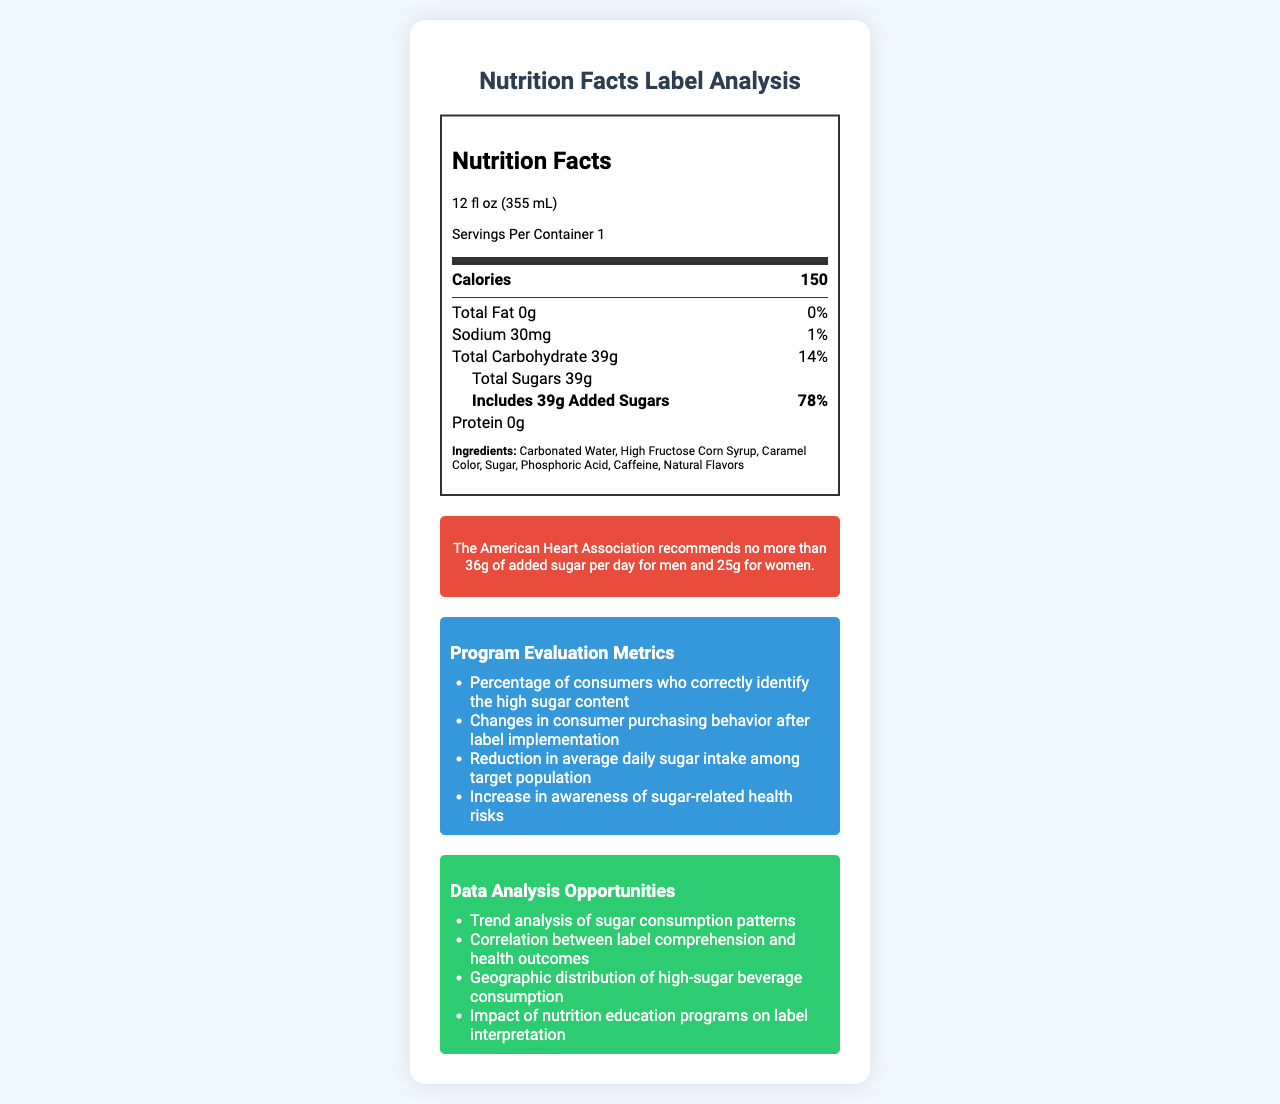what is the serving size for SweetSip Cola? The serving size is specified at the top of the nutrition label under the "Nutrition Facts" title.
Answer: 12 fl oz (355 mL) How many calories are in one serving of SweetSip Cola? The number of calories per serving is indicated in bold under the "Calories" heading on the nutrition label.
Answer: 150 How much total carbohydrate is in one serving of SweetSip Cola? The total carbohydrate amount is listed in the nutrition information as "Total Carbohydrate 39g".
Answer: 39g what is the percent daily value of sodium in SweetSip Cola? The percent daily value for sodium is shown next to the sodium amount as "1%".
Answer: 1% How much added sugar does SweetSip Cola contain? The amount of added sugars is listed under the carbohydrate section of the nutrition label as "Includes 39g Added Sugars".
Answer: 39g Which ingredient appears first on the list for SweetSip Cola? The first ingredient listed in the ingredients section is "Carbonated Water".
Answer: Carbonated Water What percent of the daily value of added sugars does one serving provide? A. 36% B. 50% C. 78% The percent daily value for added sugars is shown as "78%" next to the added sugars amount.
Answer: C. 78% What is the total fat content in SweetSip Cola? A. 0g B. 5g C. 10g D. 15g The total fat content is listed under the nutrients section as "Total Fat 0g".
Answer: A. 0g Does SweetSip Cola contain any protein? The protein amount is specified to be "0g" in the nutrition label.
Answer: No Does SweetSip Cola contain any Vitamin D? The nutrition label lists "0%" for Vitamin D in the nutrients section.
Answer: No What does the public health message recommend the maximum amount of added sugar per day for men? The public health message specifies that the American Heart Association recommends no more than 36g of added sugar per day for men.
Answer: No more than 36g What are some of the key program evaluation metrics mentioned? The program evaluation metrics are listed in the evaluation metrics section of the document.
Answer: Percentage of consumers who correctly identify the high sugar content, Changes in consumer purchasing behavior after label implementation, Reduction in average daily sugar intake among target population, Increase in awareness of sugar-related health risks Summarize the purpose of the document. The document's main goal is to provide comprehensive nutritional information, raise awareness about high sugar consumption, describe metrics for program evaluation, and suggest opportunities for data analysis.
Answer: The document presents the Nutrition Facts Label for SweetSip Cola, highlighting its high calorie and sugar content. It includes detailed nutritional information, ingredient lists, a public health message about sugar consumption, program evaluation metrics, and data analysis opportunities. What is the percentage of daily value for calcium in SweetSip Cola? The nutrition label specifies that the percentage of daily value for calcium is "0%".
Answer: 0% What flavor or natural flavoring is used in SweetSip Cola? The document only mentions "Natural Flavors" without specifying which exact flavors are used.
Answer: Cannot be determined 